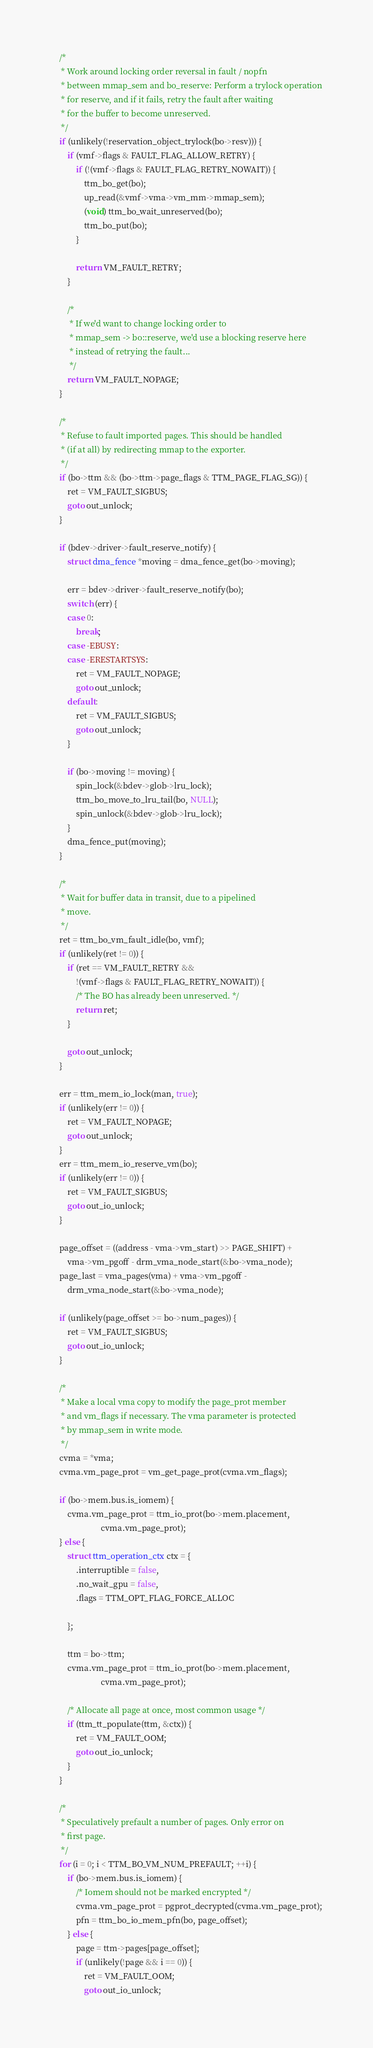<code> <loc_0><loc_0><loc_500><loc_500><_C_>
	/*
	 * Work around locking order reversal in fault / nopfn
	 * between mmap_sem and bo_reserve: Perform a trylock operation
	 * for reserve, and if it fails, retry the fault after waiting
	 * for the buffer to become unreserved.
	 */
	if (unlikely(!reservation_object_trylock(bo->resv))) {
		if (vmf->flags & FAULT_FLAG_ALLOW_RETRY) {
			if (!(vmf->flags & FAULT_FLAG_RETRY_NOWAIT)) {
				ttm_bo_get(bo);
				up_read(&vmf->vma->vm_mm->mmap_sem);
				(void) ttm_bo_wait_unreserved(bo);
				ttm_bo_put(bo);
			}

			return VM_FAULT_RETRY;
		}

		/*
		 * If we'd want to change locking order to
		 * mmap_sem -> bo::reserve, we'd use a blocking reserve here
		 * instead of retrying the fault...
		 */
		return VM_FAULT_NOPAGE;
	}

	/*
	 * Refuse to fault imported pages. This should be handled
	 * (if at all) by redirecting mmap to the exporter.
	 */
	if (bo->ttm && (bo->ttm->page_flags & TTM_PAGE_FLAG_SG)) {
		ret = VM_FAULT_SIGBUS;
		goto out_unlock;
	}

	if (bdev->driver->fault_reserve_notify) {
		struct dma_fence *moving = dma_fence_get(bo->moving);

		err = bdev->driver->fault_reserve_notify(bo);
		switch (err) {
		case 0:
			break;
		case -EBUSY:
		case -ERESTARTSYS:
			ret = VM_FAULT_NOPAGE;
			goto out_unlock;
		default:
			ret = VM_FAULT_SIGBUS;
			goto out_unlock;
		}

		if (bo->moving != moving) {
			spin_lock(&bdev->glob->lru_lock);
			ttm_bo_move_to_lru_tail(bo, NULL);
			spin_unlock(&bdev->glob->lru_lock);
		}
		dma_fence_put(moving);
	}

	/*
	 * Wait for buffer data in transit, due to a pipelined
	 * move.
	 */
	ret = ttm_bo_vm_fault_idle(bo, vmf);
	if (unlikely(ret != 0)) {
		if (ret == VM_FAULT_RETRY &&
		    !(vmf->flags & FAULT_FLAG_RETRY_NOWAIT)) {
			/* The BO has already been unreserved. */
			return ret;
		}

		goto out_unlock;
	}

	err = ttm_mem_io_lock(man, true);
	if (unlikely(err != 0)) {
		ret = VM_FAULT_NOPAGE;
		goto out_unlock;
	}
	err = ttm_mem_io_reserve_vm(bo);
	if (unlikely(err != 0)) {
		ret = VM_FAULT_SIGBUS;
		goto out_io_unlock;
	}

	page_offset = ((address - vma->vm_start) >> PAGE_SHIFT) +
		vma->vm_pgoff - drm_vma_node_start(&bo->vma_node);
	page_last = vma_pages(vma) + vma->vm_pgoff -
		drm_vma_node_start(&bo->vma_node);

	if (unlikely(page_offset >= bo->num_pages)) {
		ret = VM_FAULT_SIGBUS;
		goto out_io_unlock;
	}

	/*
	 * Make a local vma copy to modify the page_prot member
	 * and vm_flags if necessary. The vma parameter is protected
	 * by mmap_sem in write mode.
	 */
	cvma = *vma;
	cvma.vm_page_prot = vm_get_page_prot(cvma.vm_flags);

	if (bo->mem.bus.is_iomem) {
		cvma.vm_page_prot = ttm_io_prot(bo->mem.placement,
						cvma.vm_page_prot);
	} else {
		struct ttm_operation_ctx ctx = {
			.interruptible = false,
			.no_wait_gpu = false,
			.flags = TTM_OPT_FLAG_FORCE_ALLOC

		};

		ttm = bo->ttm;
		cvma.vm_page_prot = ttm_io_prot(bo->mem.placement,
						cvma.vm_page_prot);

		/* Allocate all page at once, most common usage */
		if (ttm_tt_populate(ttm, &ctx)) {
			ret = VM_FAULT_OOM;
			goto out_io_unlock;
		}
	}

	/*
	 * Speculatively prefault a number of pages. Only error on
	 * first page.
	 */
	for (i = 0; i < TTM_BO_VM_NUM_PREFAULT; ++i) {
		if (bo->mem.bus.is_iomem) {
			/* Iomem should not be marked encrypted */
			cvma.vm_page_prot = pgprot_decrypted(cvma.vm_page_prot);
			pfn = ttm_bo_io_mem_pfn(bo, page_offset);
		} else {
			page = ttm->pages[page_offset];
			if (unlikely(!page && i == 0)) {
				ret = VM_FAULT_OOM;
				goto out_io_unlock;</code> 